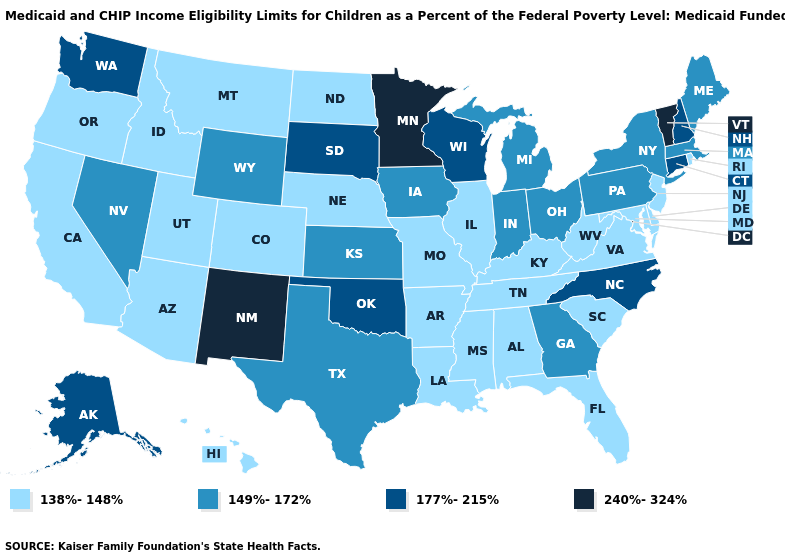Among the states that border Maine , which have the lowest value?
Give a very brief answer. New Hampshire. Does South Carolina have a lower value than Texas?
Answer briefly. Yes. What is the value of New Jersey?
Give a very brief answer. 138%-148%. Which states hav the highest value in the South?
Concise answer only. North Carolina, Oklahoma. Does the map have missing data?
Keep it brief. No. Name the states that have a value in the range 177%-215%?
Quick response, please. Alaska, Connecticut, New Hampshire, North Carolina, Oklahoma, South Dakota, Washington, Wisconsin. Which states have the lowest value in the MidWest?
Keep it brief. Illinois, Missouri, Nebraska, North Dakota. Among the states that border West Virginia , does Virginia have the lowest value?
Keep it brief. Yes. Name the states that have a value in the range 149%-172%?
Quick response, please. Georgia, Indiana, Iowa, Kansas, Maine, Massachusetts, Michigan, Nevada, New York, Ohio, Pennsylvania, Texas, Wyoming. Does Oklahoma have the lowest value in the USA?
Keep it brief. No. What is the lowest value in the USA?
Keep it brief. 138%-148%. What is the highest value in states that border West Virginia?
Give a very brief answer. 149%-172%. Name the states that have a value in the range 138%-148%?
Keep it brief. Alabama, Arizona, Arkansas, California, Colorado, Delaware, Florida, Hawaii, Idaho, Illinois, Kentucky, Louisiana, Maryland, Mississippi, Missouri, Montana, Nebraska, New Jersey, North Dakota, Oregon, Rhode Island, South Carolina, Tennessee, Utah, Virginia, West Virginia. Does the first symbol in the legend represent the smallest category?
Answer briefly. Yes. Name the states that have a value in the range 177%-215%?
Concise answer only. Alaska, Connecticut, New Hampshire, North Carolina, Oklahoma, South Dakota, Washington, Wisconsin. 